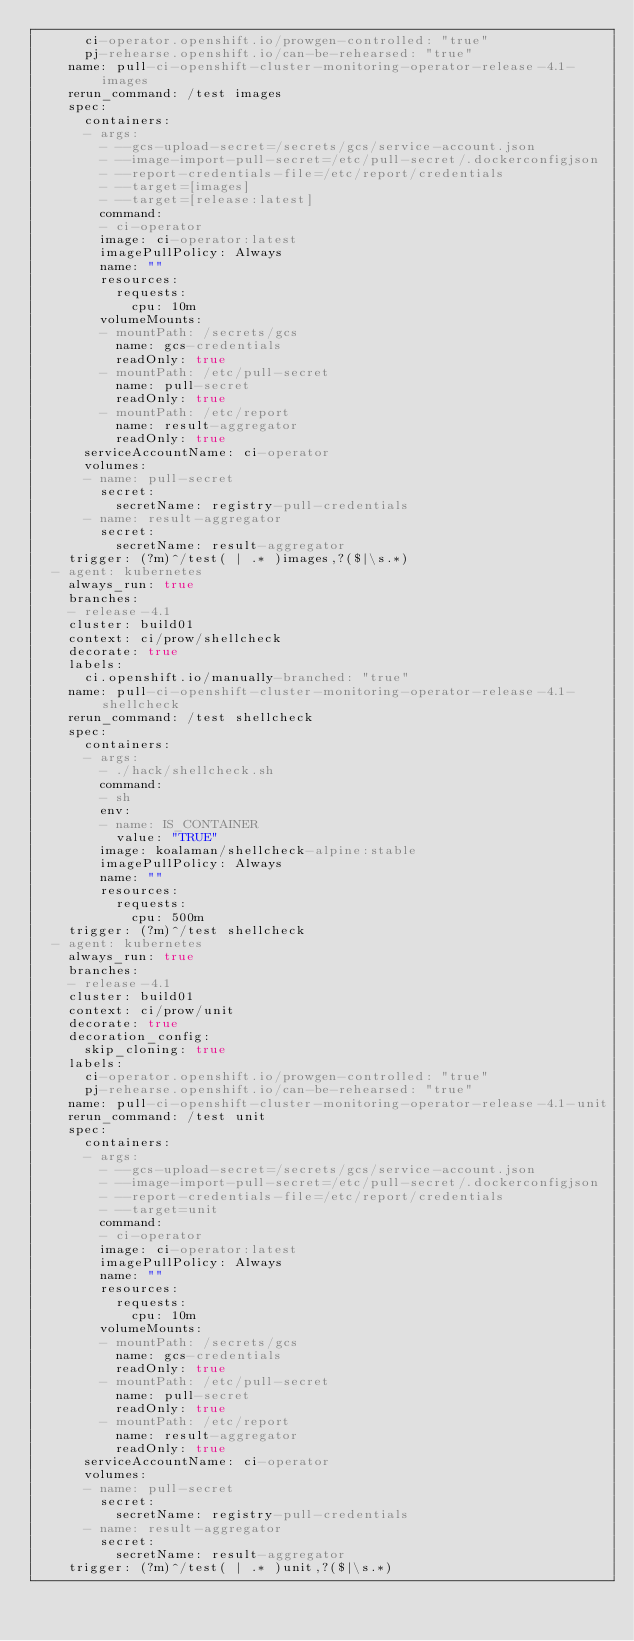<code> <loc_0><loc_0><loc_500><loc_500><_YAML_>      ci-operator.openshift.io/prowgen-controlled: "true"
      pj-rehearse.openshift.io/can-be-rehearsed: "true"
    name: pull-ci-openshift-cluster-monitoring-operator-release-4.1-images
    rerun_command: /test images
    spec:
      containers:
      - args:
        - --gcs-upload-secret=/secrets/gcs/service-account.json
        - --image-import-pull-secret=/etc/pull-secret/.dockerconfigjson
        - --report-credentials-file=/etc/report/credentials
        - --target=[images]
        - --target=[release:latest]
        command:
        - ci-operator
        image: ci-operator:latest
        imagePullPolicy: Always
        name: ""
        resources:
          requests:
            cpu: 10m
        volumeMounts:
        - mountPath: /secrets/gcs
          name: gcs-credentials
          readOnly: true
        - mountPath: /etc/pull-secret
          name: pull-secret
          readOnly: true
        - mountPath: /etc/report
          name: result-aggregator
          readOnly: true
      serviceAccountName: ci-operator
      volumes:
      - name: pull-secret
        secret:
          secretName: registry-pull-credentials
      - name: result-aggregator
        secret:
          secretName: result-aggregator
    trigger: (?m)^/test( | .* )images,?($|\s.*)
  - agent: kubernetes
    always_run: true
    branches:
    - release-4.1
    cluster: build01
    context: ci/prow/shellcheck
    decorate: true
    labels:
      ci.openshift.io/manually-branched: "true"
    name: pull-ci-openshift-cluster-monitoring-operator-release-4.1-shellcheck
    rerun_command: /test shellcheck
    spec:
      containers:
      - args:
        - ./hack/shellcheck.sh
        command:
        - sh
        env:
        - name: IS_CONTAINER
          value: "TRUE"
        image: koalaman/shellcheck-alpine:stable
        imagePullPolicy: Always
        name: ""
        resources:
          requests:
            cpu: 500m
    trigger: (?m)^/test shellcheck
  - agent: kubernetes
    always_run: true
    branches:
    - release-4.1
    cluster: build01
    context: ci/prow/unit
    decorate: true
    decoration_config:
      skip_cloning: true
    labels:
      ci-operator.openshift.io/prowgen-controlled: "true"
      pj-rehearse.openshift.io/can-be-rehearsed: "true"
    name: pull-ci-openshift-cluster-monitoring-operator-release-4.1-unit
    rerun_command: /test unit
    spec:
      containers:
      - args:
        - --gcs-upload-secret=/secrets/gcs/service-account.json
        - --image-import-pull-secret=/etc/pull-secret/.dockerconfigjson
        - --report-credentials-file=/etc/report/credentials
        - --target=unit
        command:
        - ci-operator
        image: ci-operator:latest
        imagePullPolicy: Always
        name: ""
        resources:
          requests:
            cpu: 10m
        volumeMounts:
        - mountPath: /secrets/gcs
          name: gcs-credentials
          readOnly: true
        - mountPath: /etc/pull-secret
          name: pull-secret
          readOnly: true
        - mountPath: /etc/report
          name: result-aggregator
          readOnly: true
      serviceAccountName: ci-operator
      volumes:
      - name: pull-secret
        secret:
          secretName: registry-pull-credentials
      - name: result-aggregator
        secret:
          secretName: result-aggregator
    trigger: (?m)^/test( | .* )unit,?($|\s.*)
</code> 